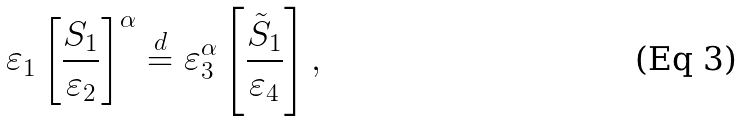<formula> <loc_0><loc_0><loc_500><loc_500>\varepsilon _ { 1 } \left [ \frac { S _ { 1 } } { \varepsilon _ { 2 } } \right ] ^ { \alpha } \stackrel { d } { = } \varepsilon _ { 3 } ^ { \alpha } \left [ \frac { \tilde { S } _ { 1 } } { \varepsilon _ { 4 } } \right ] ,</formula> 